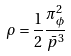Convert formula to latex. <formula><loc_0><loc_0><loc_500><loc_500>\rho = \frac { 1 } { 2 } \frac { \pi ^ { 2 } _ { \phi } } { \bar { p } ^ { 3 } }</formula> 